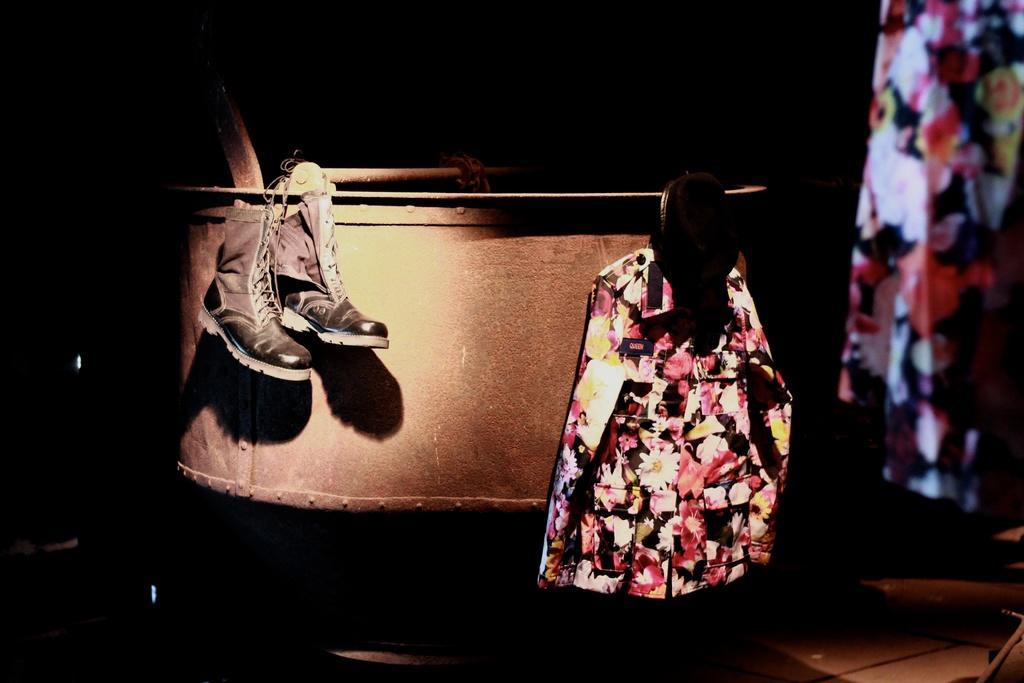Describe this image in one or two sentences. This picture is taken in a dark room. In the center, there is a metal structure. On the metal structures, there are boots and a shirt with a flower pattern are hanged to it. Towards the top right, there is a cloth with flower pattern. 